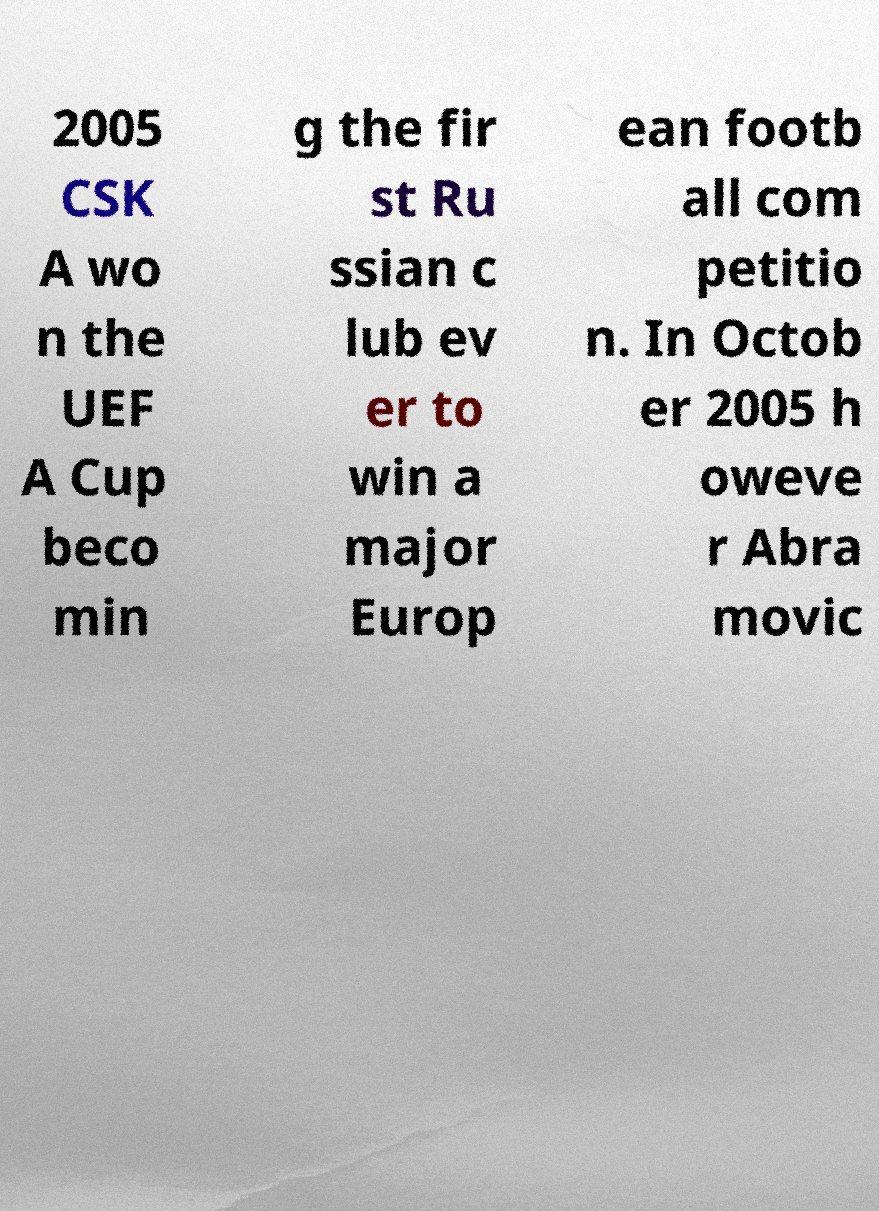I need the written content from this picture converted into text. Can you do that? 2005 CSK A wo n the UEF A Cup beco min g the fir st Ru ssian c lub ev er to win a major Europ ean footb all com petitio n. In Octob er 2005 h oweve r Abra movic 